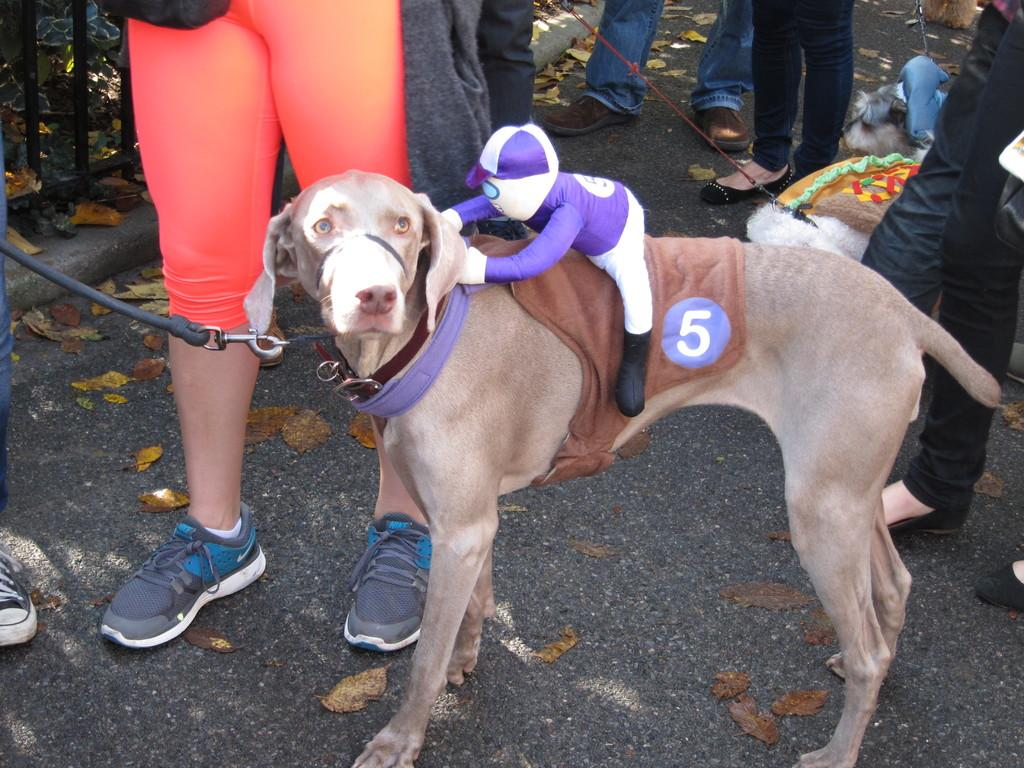What type of animals can be seen in the image? There are dogs in the image. What else is visible in the image besides the dogs? There are legs of persons, leaves on the ground, a fence, and a toy on one of the dogs in the image. What type of apple is being used to cover the fence in the image? There is no apple present in the image, nor is there any indication that the fence is being covered by anything. 